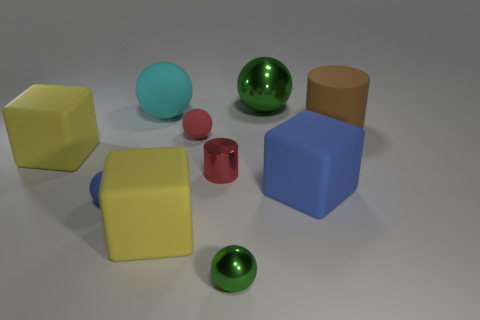Subtract all green metallic balls. How many balls are left? 3 Subtract all blue blocks. How many green spheres are left? 2 Subtract 3 spheres. How many spheres are left? 2 Subtract all red balls. How many balls are left? 4 Subtract all cylinders. How many objects are left? 8 Subtract all blue spheres. Subtract all purple blocks. How many spheres are left? 4 Subtract all tiny matte things. Subtract all large blue matte cubes. How many objects are left? 7 Add 5 large cyan balls. How many large cyan balls are left? 6 Add 5 yellow rubber blocks. How many yellow rubber blocks exist? 7 Subtract 0 red cubes. How many objects are left? 10 